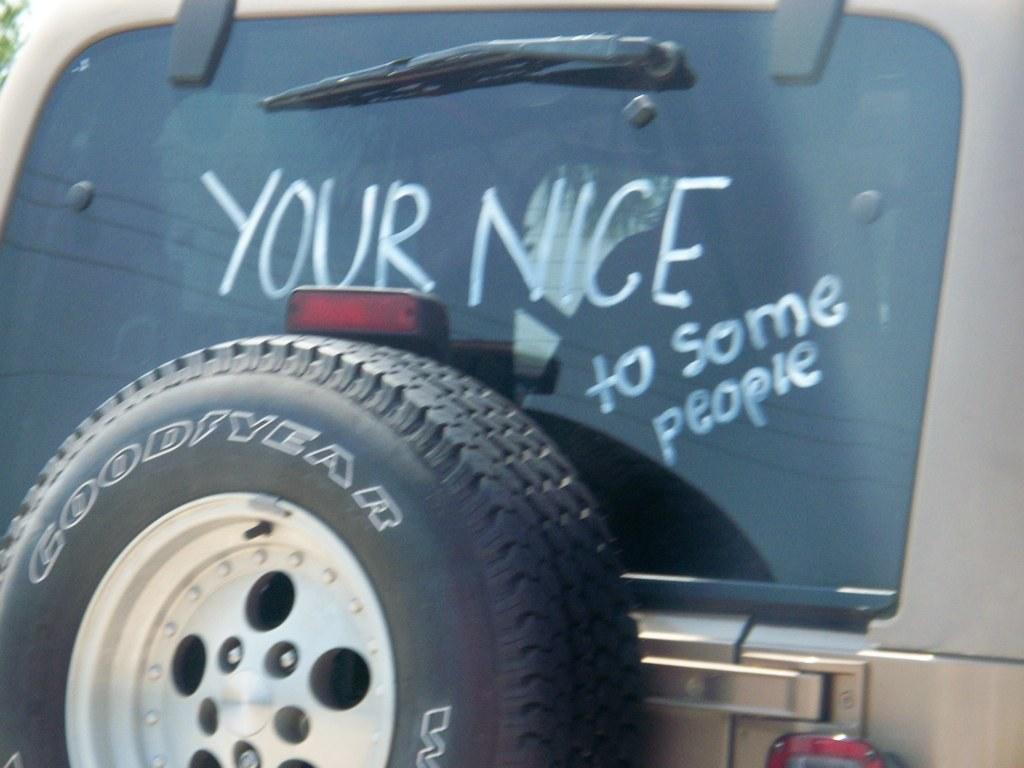What part of a vehicle is shown in the image? The back window of a vehicle is shown in the image. What can be seen on the back window? There is text visible on the back window. Is there any other part of the vehicle visible in the image? Yes, there is a tire attached to the back window. What type of stitch is used to sew the pocket on the back window of the vehicle in the image? There is no pocket present on the back window of the vehicle in the image. 